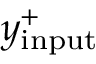<formula> <loc_0><loc_0><loc_500><loc_500>y _ { i n p u t } ^ { + }</formula> 